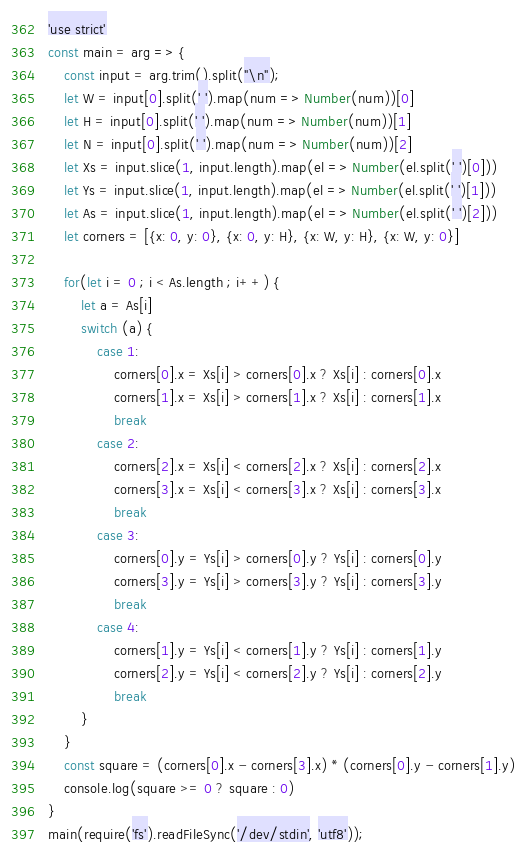<code> <loc_0><loc_0><loc_500><loc_500><_JavaScript_>'use strict'
const main = arg => {
	const input = arg.trim().split("\n");
	let W = input[0].split(' ').map(num => Number(num))[0]
	let H = input[0].split(' ').map(num => Number(num))[1]
	let N = input[0].split(' ').map(num => Number(num))[2]
	let Xs = input.slice(1, input.length).map(el => Number(el.split(' ')[0]))
	let Ys = input.slice(1, input.length).map(el => Number(el.split(' ')[1]))
	let As = input.slice(1, input.length).map(el => Number(el.split(' ')[2]))
	let corners = [{x: 0, y: 0}, {x: 0, y: H}, {x: W, y: H}, {x: W, y: 0}]

	for(let i = 0 ; i < As.length ; i++) {
		let a = As[i]
		switch (a) {
			case 1:
				corners[0].x = Xs[i] > corners[0].x ? Xs[i] : corners[0].x
				corners[1].x = Xs[i] > corners[1].x ? Xs[i] : corners[1].x
				break
			case 2:
				corners[2].x = Xs[i] < corners[2].x ? Xs[i] : corners[2].x
				corners[3].x = Xs[i] < corners[3].x ? Xs[i] : corners[3].x
				break
			case 3:
				corners[0].y = Ys[i] > corners[0].y ? Ys[i] : corners[0].y
				corners[3].y = Ys[i] > corners[3].y ? Ys[i] : corners[3].y
				break
			case 4:
				corners[1].y = Ys[i] < corners[1].y ? Ys[i] : corners[1].y
				corners[2].y = Ys[i] < corners[2].y ? Ys[i] : corners[2].y
				break
		}
	}
	const square = (corners[0].x - corners[3].x) * (corners[0].y - corners[1].y)
	console.log(square >= 0 ? square : 0)
}   
main(require('fs').readFileSync('/dev/stdin', 'utf8'));</code> 